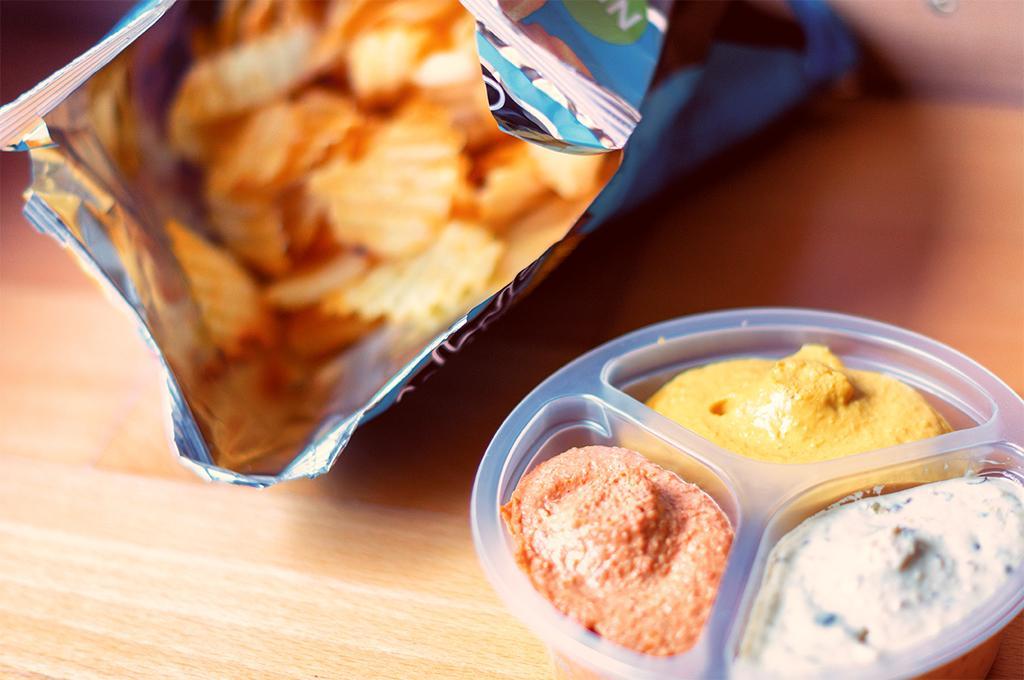Describe this image in one or two sentences. In this picture we can see a chips packet, bowl with food items in it and these are placed on a wooden table. 